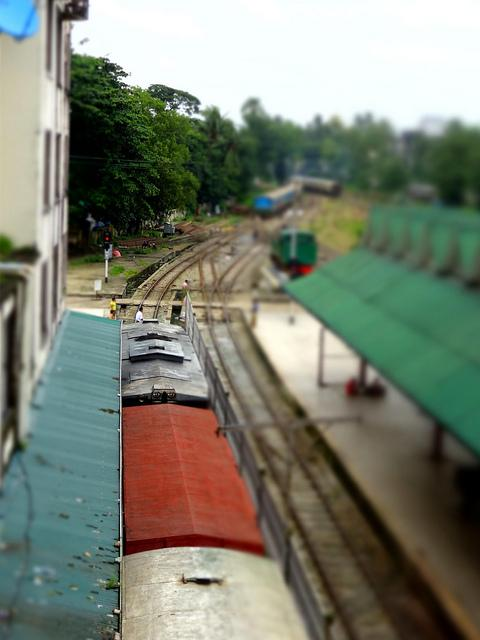What color is the train car in the center of the three cars?

Choices:
A) red
B) blue
C) gray
D) white red 